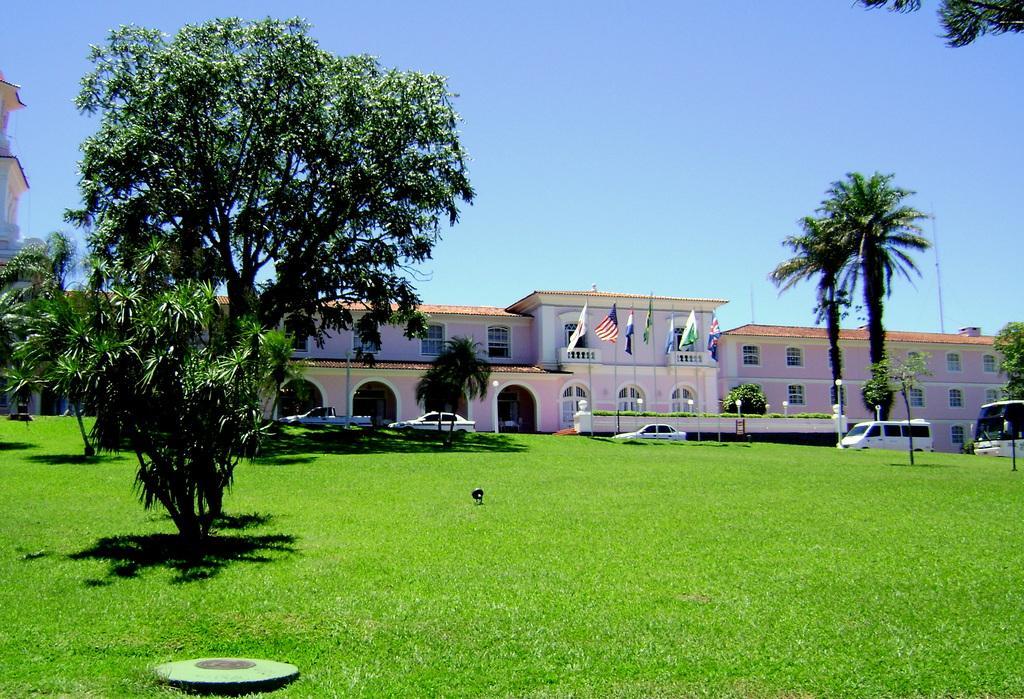Can you describe this image briefly? In this image we can see some trees and grass on the ground and there are some vehicles. We can see a building and there are some flags in front of the building and on the left side of the image we can see a building and at the top we can see the sky. 